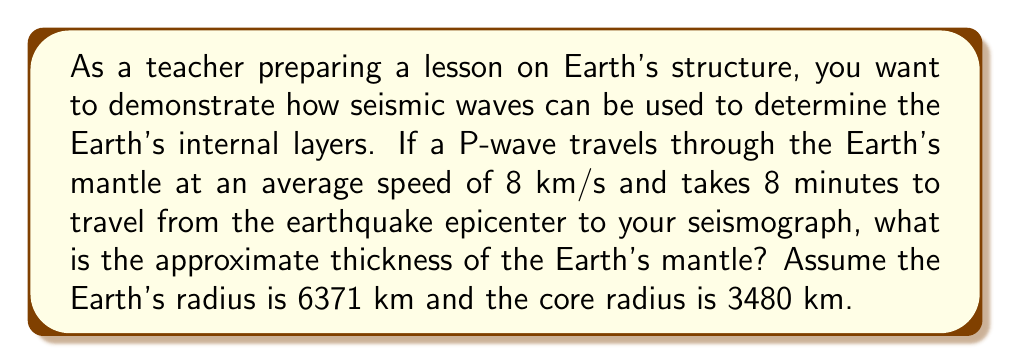Teach me how to tackle this problem. Let's approach this step-by-step:

1) First, we need to calculate the distance the P-wave traveled:
   Distance = Speed × Time
   $$d = 8 \frac{km}{s} \times (8 \times 60) s = 3840 km$$

2) The wave travels through the mantle twice (down and up), so the actual mantle thickness is half of this:
   $$\text{Mantle thickness} = \frac{3840}{2} = 1920 km$$

3) However, this is just a straight-line approximation. To get a more accurate result, we need to consider the Earth's curvature.

4) The total radius of the Earth minus the core radius gives us the actual mantle thickness:
   $$\text{Actual mantle thickness} = 6371 km - 3480 km = 2891 km$$

5) Our calculated thickness (1920 km) is less than the actual thickness because the wave doesn't travel in a straight line through the mantle.

6) To account for this, we can use the arc length formula:
   $$s = r\theta$$
   Where $s$ is the arc length (3840 km), $r$ is the average radius to the middle of the mantle ($(6371 + 3480)/2 = 4925.5 km$), and $\theta$ is the central angle in radians.

7) Solving for $\theta$:
   $$\theta = \frac{s}{r} = \frac{3840}{4925.5} \approx 0.7796 \text{ radians}$$

8) The straight-line distance through the mantle is:
   $$2r \sin(\frac{\theta}{2}) = 2 \times 4925.5 \times \sin(0.3898) \approx 3738 km$$

9) Therefore, the approximate mantle thickness is:
   $$\text{Mantle thickness} \approx \frac{3738}{2} = 1869 km$$

This is closer to the actual mantle thickness, considering the simplifications in our model.
Answer: Approximately 1869 km 